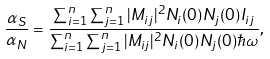Convert formula to latex. <formula><loc_0><loc_0><loc_500><loc_500>\frac { \alpha _ { S } } { \alpha _ { N } } = \frac { \sum _ { i = 1 } ^ { n } \sum _ { j = 1 } ^ { n } | M _ { i j } | ^ { 2 } N _ { i } ( 0 ) N _ { j } ( 0 ) I _ { i j } } { \sum _ { i = 1 } ^ { n } \sum _ { j = 1 } ^ { n } | M _ { i j } | ^ { 2 } N _ { i } ( 0 ) N _ { j } ( 0 ) \hbar { \omega } } ,</formula> 